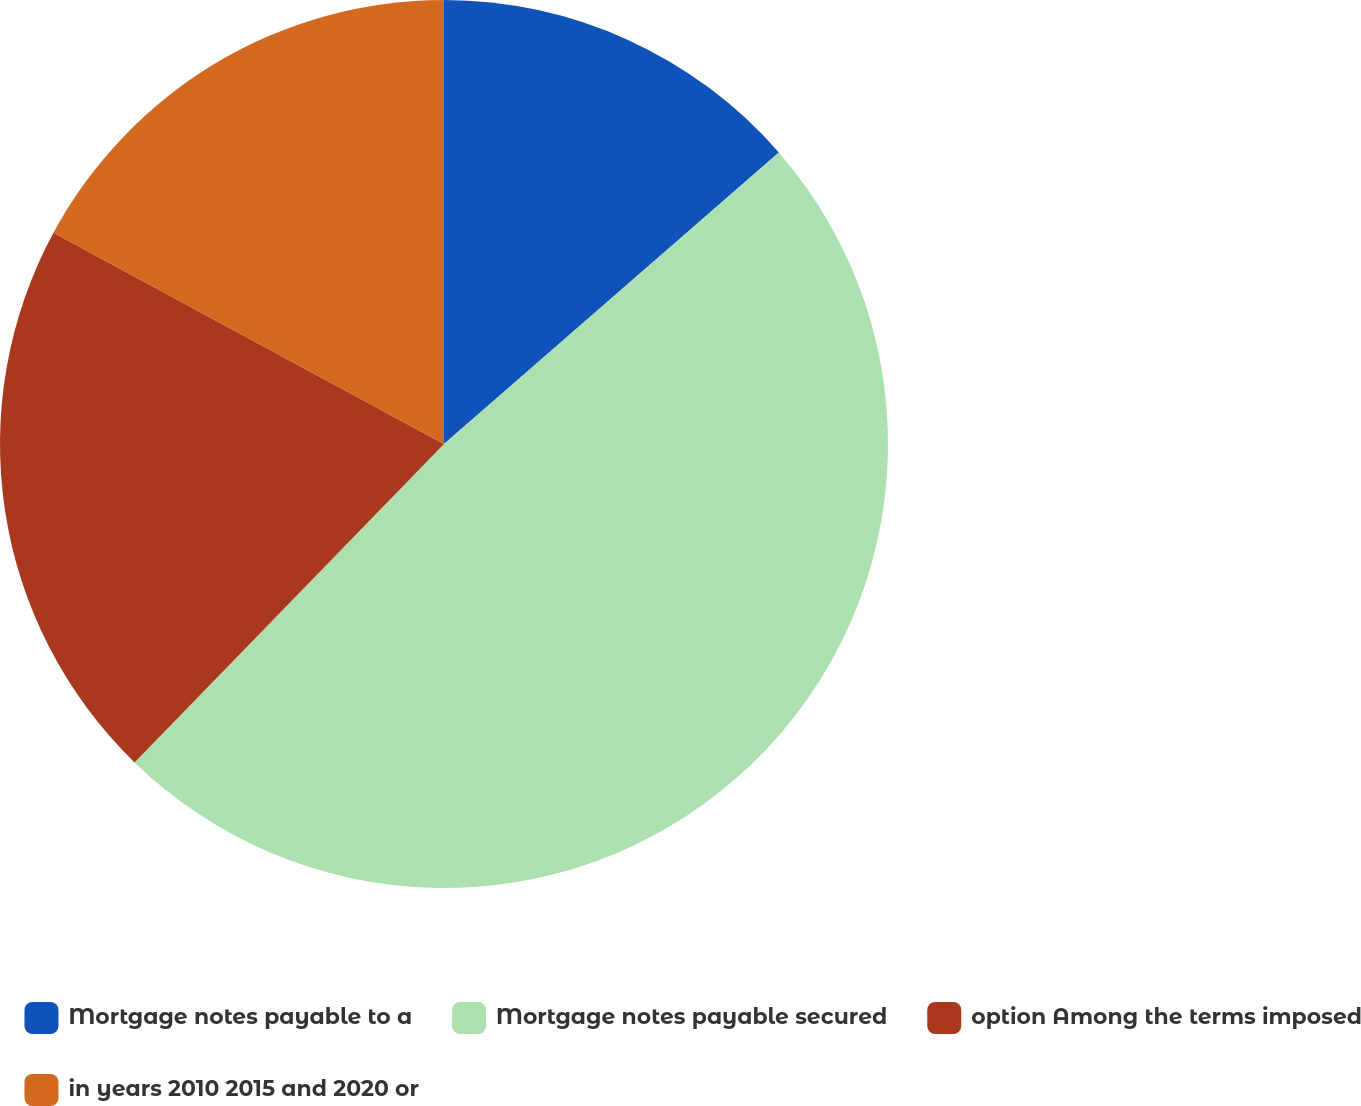Convert chart to OTSL. <chart><loc_0><loc_0><loc_500><loc_500><pie_chart><fcel>Mortgage notes payable to a<fcel>Mortgage notes payable secured<fcel>option Among the terms imposed<fcel>in years 2010 2015 and 2020 or<nl><fcel>13.6%<fcel>48.68%<fcel>20.62%<fcel>17.11%<nl></chart> 